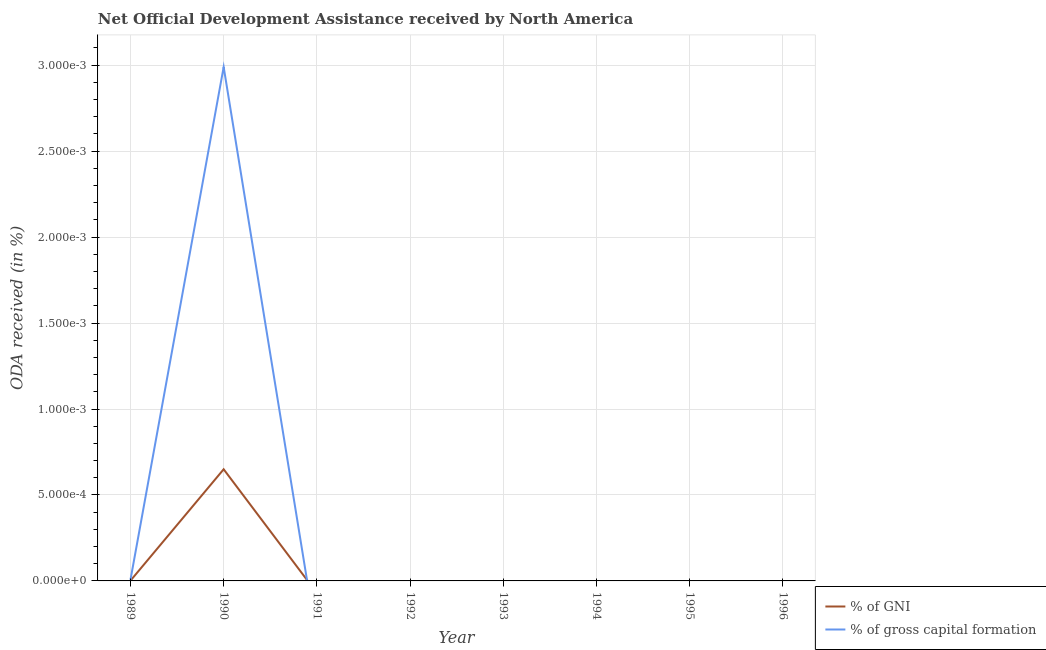How many different coloured lines are there?
Ensure brevity in your answer.  2. Is the number of lines equal to the number of legend labels?
Provide a short and direct response. No. Across all years, what is the maximum oda received as percentage of gni?
Offer a terse response. 0. What is the total oda received as percentage of gross capital formation in the graph?
Ensure brevity in your answer.  0. What is the difference between the oda received as percentage of gross capital formation in 1989 and that in 1990?
Your answer should be compact. -0. What is the difference between the oda received as percentage of gross capital formation in 1991 and the oda received as percentage of gni in 1996?
Make the answer very short. 0. What is the average oda received as percentage of gni per year?
Make the answer very short. 8.138471161796374e-5. In the year 1989, what is the difference between the oda received as percentage of gross capital formation and oda received as percentage of gni?
Ensure brevity in your answer.  5.497205311456061e-6. In how many years, is the oda received as percentage of gni greater than 0.0002 %?
Keep it short and to the point. 1. What is the ratio of the oda received as percentage of gross capital formation in 1989 to that in 1990?
Give a very brief answer. 0. What is the difference between the highest and the lowest oda received as percentage of gross capital formation?
Your response must be concise. 0. How many years are there in the graph?
Provide a short and direct response. 8. What is the difference between two consecutive major ticks on the Y-axis?
Make the answer very short. 0. Does the graph contain any zero values?
Ensure brevity in your answer.  Yes. Where does the legend appear in the graph?
Provide a succinct answer. Bottom right. What is the title of the graph?
Ensure brevity in your answer.  Net Official Development Assistance received by North America. What is the label or title of the X-axis?
Provide a succinct answer. Year. What is the label or title of the Y-axis?
Give a very brief answer. ODA received (in %). What is the ODA received (in %) of % of GNI in 1989?
Your answer should be compact. 1.62205881911487e-6. What is the ODA received (in %) of % of gross capital formation in 1989?
Make the answer very short. 7.119264130570931e-6. What is the ODA received (in %) in % of GNI in 1990?
Keep it short and to the point. 0. What is the ODA received (in %) of % of gross capital formation in 1990?
Provide a short and direct response. 0. What is the ODA received (in %) of % of gross capital formation in 1991?
Offer a very short reply. 0. What is the ODA received (in %) in % of GNI in 1992?
Ensure brevity in your answer.  0. What is the ODA received (in %) in % of GNI in 1993?
Offer a very short reply. 0. What is the ODA received (in %) of % of gross capital formation in 1993?
Provide a succinct answer. 0. What is the ODA received (in %) in % of GNI in 1994?
Keep it short and to the point. 0. What is the ODA received (in %) in % of gross capital formation in 1996?
Keep it short and to the point. 0. Across all years, what is the maximum ODA received (in %) of % of GNI?
Make the answer very short. 0. Across all years, what is the maximum ODA received (in %) of % of gross capital formation?
Keep it short and to the point. 0. What is the total ODA received (in %) in % of GNI in the graph?
Offer a very short reply. 0. What is the total ODA received (in %) in % of gross capital formation in the graph?
Provide a short and direct response. 0. What is the difference between the ODA received (in %) of % of GNI in 1989 and that in 1990?
Offer a very short reply. -0. What is the difference between the ODA received (in %) in % of gross capital formation in 1989 and that in 1990?
Your answer should be very brief. -0. What is the difference between the ODA received (in %) of % of GNI in 1989 and the ODA received (in %) of % of gross capital formation in 1990?
Give a very brief answer. -0. What is the average ODA received (in %) of % of gross capital formation per year?
Offer a very short reply. 0. In the year 1989, what is the difference between the ODA received (in %) in % of GNI and ODA received (in %) in % of gross capital formation?
Your answer should be compact. -0. In the year 1990, what is the difference between the ODA received (in %) of % of GNI and ODA received (in %) of % of gross capital formation?
Offer a terse response. -0. What is the ratio of the ODA received (in %) of % of GNI in 1989 to that in 1990?
Make the answer very short. 0. What is the ratio of the ODA received (in %) in % of gross capital formation in 1989 to that in 1990?
Provide a short and direct response. 0. What is the difference between the highest and the lowest ODA received (in %) of % of GNI?
Provide a succinct answer. 0. What is the difference between the highest and the lowest ODA received (in %) of % of gross capital formation?
Your answer should be compact. 0. 